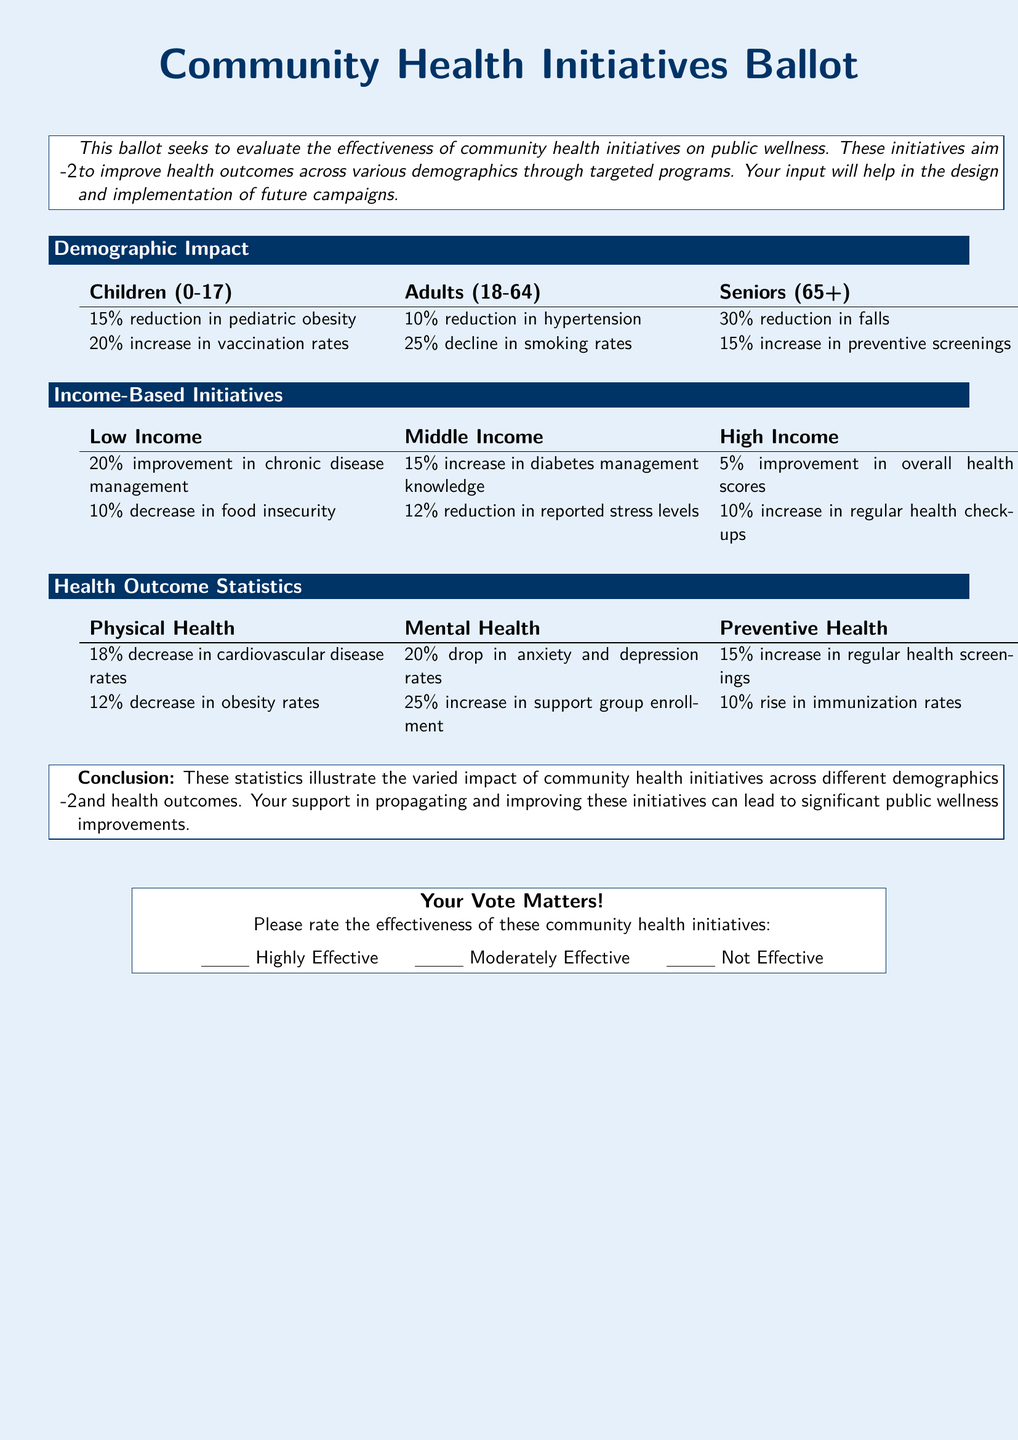What percentage reduction in pediatric obesity is reported? The document states that there is a 15% reduction in pediatric obesity among children aged 0-17.
Answer: 15% What is the reported improvement in chronic disease management for low-income individuals? It mentions a 20% improvement in chronic disease management for the low-income demographic.
Answer: 20% What decrease in anxiety and depression rates is reported? The health outcome section notes a 20% drop in anxiety and depression rates, which indicates a significant mental health improvement.
Answer: 20% Which demographic experienced a 25% decline in smoking rates? The document indicates that adults aged 18-64 experienced a 25% decline in smoking rates.
Answer: Adults (18-64) What percentage increase in vaccination rates is observed in children? According to the statistics provided, there is a 20% increase in vaccination rates among children.
Answer: 20% What percentage of seniors experienced a reduction in falls? The data shows a 30% reduction in falls among seniors aged 65 and older as a result of community health initiatives.
Answer: 30% Which income group reported a 12% reduction in stress levels? The document states that middle-income individuals reported a 12% reduction in reported stress levels.
Answer: Middle Income What does the conclusion say about the community health initiatives? The conclusion emphasizes that these statistics illustrate the varied impact of community health initiatives across different demographics and health outcomes.
Answer: Varied impact What is the purpose of this ballot? The purpose is to evaluate the effectiveness of community health initiatives on public wellness and gather input for future campaigns.
Answer: Evaluate effectiveness 